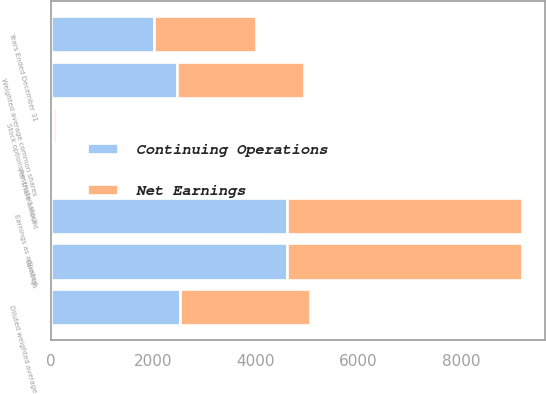<chart> <loc_0><loc_0><loc_500><loc_500><stacked_bar_chart><ecel><fcel>Years Ended December 31<fcel>Earnings<fcel>Weighted average common shares<fcel>Per share amount<fcel>Earnings as adjusted<fcel>Stock options/restricted stock<fcel>Diluted weighted average<nl><fcel>Continuing Operations<fcel>2005<fcel>4599<fcel>2471.3<fcel>1.86<fcel>4599<fcel>55.7<fcel>2527<nl><fcel>Net Earnings<fcel>2005<fcel>4578<fcel>2471.3<fcel>1.85<fcel>4578<fcel>55.7<fcel>2527<nl></chart> 